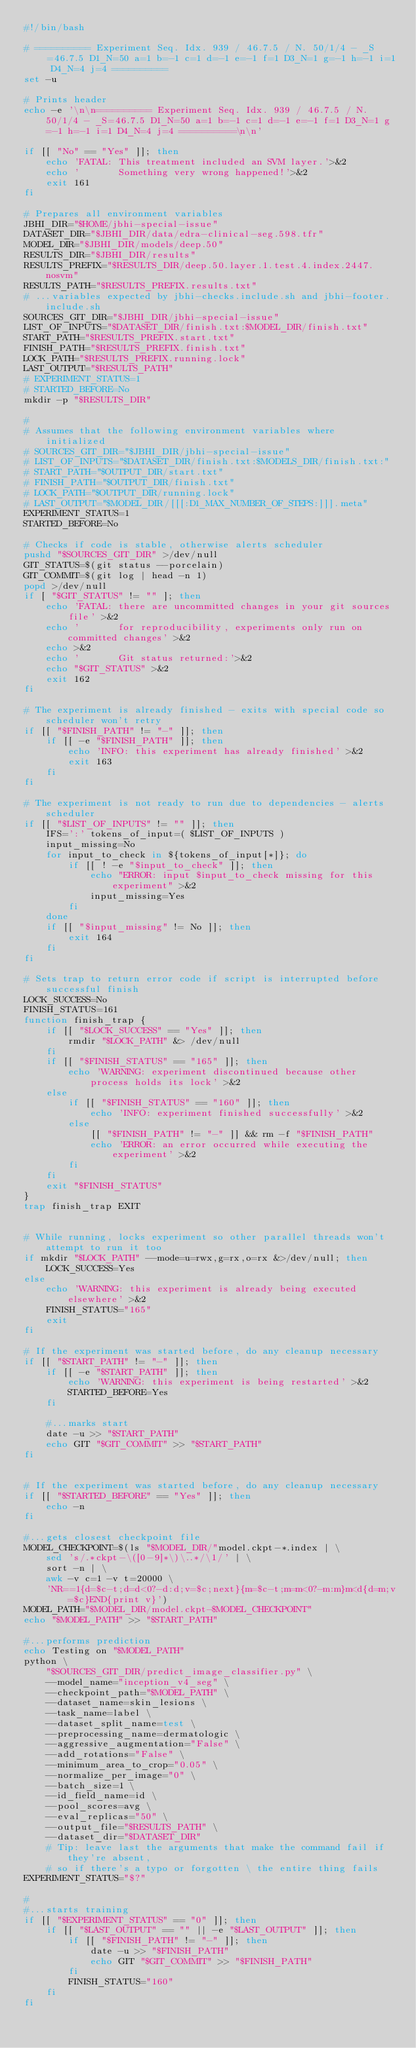Convert code to text. <code><loc_0><loc_0><loc_500><loc_500><_Bash_>#!/bin/bash

# ========== Experiment Seq. Idx. 939 / 46.7.5 / N. 50/1/4 - _S=46.7.5 D1_N=50 a=1 b=-1 c=1 d=-1 e=-1 f=1 D3_N=1 g=-1 h=-1 i=1 D4_N=4 j=4 ==========
set -u

# Prints header
echo -e '\n\n========== Experiment Seq. Idx. 939 / 46.7.5 / N. 50/1/4 - _S=46.7.5 D1_N=50 a=1 b=-1 c=1 d=-1 e=-1 f=1 D3_N=1 g=-1 h=-1 i=1 D4_N=4 j=4 ==========\n\n'

if [[ "No" == "Yes" ]]; then
    echo 'FATAL: This treatment included an SVM layer.'>&2
    echo '       Something very wrong happened!'>&2
    exit 161
fi

# Prepares all environment variables
JBHI_DIR="$HOME/jbhi-special-issue"
DATASET_DIR="$JBHI_DIR/data/edra-clinical-seg.598.tfr"
MODEL_DIR="$JBHI_DIR/models/deep.50"
RESULTS_DIR="$JBHI_DIR/results"
RESULTS_PREFIX="$RESULTS_DIR/deep.50.layer.1.test.4.index.2447.nosvm"
RESULTS_PATH="$RESULTS_PREFIX.results.txt"
# ...variables expected by jbhi-checks.include.sh and jbhi-footer.include.sh
SOURCES_GIT_DIR="$JBHI_DIR/jbhi-special-issue"
LIST_OF_INPUTS="$DATASET_DIR/finish.txt:$MODEL_DIR/finish.txt"
START_PATH="$RESULTS_PREFIX.start.txt"
FINISH_PATH="$RESULTS_PREFIX.finish.txt"
LOCK_PATH="$RESULTS_PREFIX.running.lock"
LAST_OUTPUT="$RESULTS_PATH"
# EXPERIMENT_STATUS=1
# STARTED_BEFORE=No
mkdir -p "$RESULTS_DIR"

#
# Assumes that the following environment variables where initialized
# SOURCES_GIT_DIR="$JBHI_DIR/jbhi-special-issue"
# LIST_OF_INPUTS="$DATASET_DIR/finish.txt:$MODELS_DIR/finish.txt:"
# START_PATH="$OUTPUT_DIR/start.txt"
# FINISH_PATH="$OUTPUT_DIR/finish.txt"
# LOCK_PATH="$OUTPUT_DIR/running.lock"
# LAST_OUTPUT="$MODEL_DIR/[[[:D1_MAX_NUMBER_OF_STEPS:]]].meta"
EXPERIMENT_STATUS=1
STARTED_BEFORE=No

# Checks if code is stable, otherwise alerts scheduler
pushd "$SOURCES_GIT_DIR" >/dev/null
GIT_STATUS=$(git status --porcelain)
GIT_COMMIT=$(git log | head -n 1)
popd >/dev/null
if [ "$GIT_STATUS" != "" ]; then
    echo 'FATAL: there are uncommitted changes in your git sources file' >&2
    echo '       for reproducibility, experiments only run on committed changes' >&2
    echo >&2
    echo '       Git status returned:'>&2
    echo "$GIT_STATUS" >&2
    exit 162
fi

# The experiment is already finished - exits with special code so scheduler won't retry
if [[ "$FINISH_PATH" != "-" ]]; then
    if [[ -e "$FINISH_PATH" ]]; then
        echo 'INFO: this experiment has already finished' >&2
        exit 163
    fi
fi

# The experiment is not ready to run due to dependencies - alerts scheduler
if [[ "$LIST_OF_INPUTS" != "" ]]; then
    IFS=':' tokens_of_input=( $LIST_OF_INPUTS )
    input_missing=No
    for input_to_check in ${tokens_of_input[*]}; do
        if [[ ! -e "$input_to_check" ]]; then
            echo "ERROR: input $input_to_check missing for this experiment" >&2
            input_missing=Yes
        fi
    done
    if [[ "$input_missing" != No ]]; then
        exit 164
    fi
fi

# Sets trap to return error code if script is interrupted before successful finish
LOCK_SUCCESS=No
FINISH_STATUS=161
function finish_trap {
    if [[ "$LOCK_SUCCESS" == "Yes" ]]; then
        rmdir "$LOCK_PATH" &> /dev/null
    fi
    if [[ "$FINISH_STATUS" == "165" ]]; then
        echo 'WARNING: experiment discontinued because other process holds its lock' >&2
    else
        if [[ "$FINISH_STATUS" == "160" ]]; then
            echo 'INFO: experiment finished successfully' >&2
        else
            [[ "$FINISH_PATH" != "-" ]] && rm -f "$FINISH_PATH"
            echo 'ERROR: an error occurred while executing the experiment' >&2
        fi
    fi
    exit "$FINISH_STATUS"
}
trap finish_trap EXIT


# While running, locks experiment so other parallel threads won't attempt to run it too
if mkdir "$LOCK_PATH" --mode=u=rwx,g=rx,o=rx &>/dev/null; then
    LOCK_SUCCESS=Yes
else
    echo 'WARNING: this experiment is already being executed elsewhere' >&2
    FINISH_STATUS="165"
    exit
fi

# If the experiment was started before, do any cleanup necessary
if [[ "$START_PATH" != "-" ]]; then
    if [[ -e "$START_PATH" ]]; then
        echo 'WARNING: this experiment is being restarted' >&2
        STARTED_BEFORE=Yes
    fi

    #...marks start
    date -u >> "$START_PATH"
    echo GIT "$GIT_COMMIT" >> "$START_PATH"
fi


# If the experiment was started before, do any cleanup necessary
if [[ "$STARTED_BEFORE" == "Yes" ]]; then
    echo -n
fi

#...gets closest checkpoint file
MODEL_CHECKPOINT=$(ls "$MODEL_DIR/"model.ckpt-*.index | \
    sed 's/.*ckpt-\([0-9]*\)\..*/\1/' | \
    sort -n | \
    awk -v c=1 -v t=20000 \
    'NR==1{d=$c-t;d=d<0?-d:d;v=$c;next}{m=$c-t;m=m<0?-m:m}m<d{d=m;v=$c}END{print v}')
MODEL_PATH="$MODEL_DIR/model.ckpt-$MODEL_CHECKPOINT"
echo "$MODEL_PATH" >> "$START_PATH"

#...performs prediction
echo Testing on "$MODEL_PATH"
python \
    "$SOURCES_GIT_DIR/predict_image_classifier.py" \
    --model_name="inception_v4_seg" \
    --checkpoint_path="$MODEL_PATH" \
    --dataset_name=skin_lesions \
    --task_name=label \
    --dataset_split_name=test \
    --preprocessing_name=dermatologic \
    --aggressive_augmentation="False" \
    --add_rotations="False" \
    --minimum_area_to_crop="0.05" \
    --normalize_per_image="0" \
    --batch_size=1 \
    --id_field_name=id \
    --pool_scores=avg \
    --eval_replicas="50" \
    --output_file="$RESULTS_PATH" \
    --dataset_dir="$DATASET_DIR"
    # Tip: leave last the arguments that make the command fail if they're absent,
    # so if there's a typo or forgotten \ the entire thing fails
EXPERIMENT_STATUS="$?"

#
#...starts training
if [[ "$EXPERIMENT_STATUS" == "0" ]]; then
    if [[ "$LAST_OUTPUT" == "" || -e "$LAST_OUTPUT" ]]; then
        if [[ "$FINISH_PATH" != "-" ]]; then
            date -u >> "$FINISH_PATH"
            echo GIT "$GIT_COMMIT" >> "$FINISH_PATH"
        fi
        FINISH_STATUS="160"
    fi
fi



</code> 